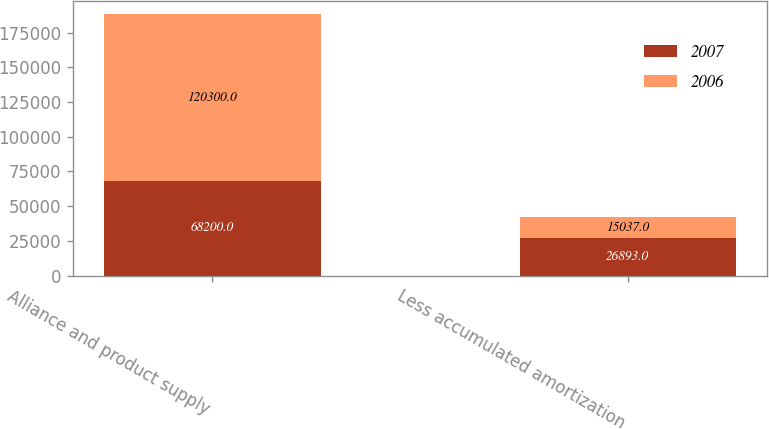<chart> <loc_0><loc_0><loc_500><loc_500><stacked_bar_chart><ecel><fcel>Alliance and product supply<fcel>Less accumulated amortization<nl><fcel>2007<fcel>68200<fcel>26893<nl><fcel>2006<fcel>120300<fcel>15037<nl></chart> 